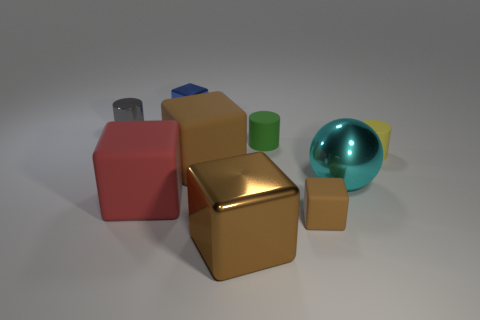Does the metallic sphere have the same size as the metallic object in front of the large metal sphere?
Provide a succinct answer. Yes. Are there an equal number of large brown metal cubes that are left of the gray metal cylinder and small yellow cylinders that are to the right of the small green matte cylinder?
Keep it short and to the point. No. What is the shape of the matte thing that is the same color as the tiny rubber block?
Offer a very short reply. Cube. There is a cylinder on the left side of the blue metallic thing; what is its material?
Your answer should be compact. Metal. Do the green rubber cylinder and the brown shiny object have the same size?
Keep it short and to the point. No. Are there more matte cylinders that are on the left side of the big brown metallic block than large red cylinders?
Keep it short and to the point. No. What size is the green cylinder that is the same material as the red block?
Give a very brief answer. Small. There is a small yellow rubber cylinder; are there any red matte blocks behind it?
Give a very brief answer. No. Do the blue thing and the big brown metal thing have the same shape?
Make the answer very short. Yes. There is a brown matte object that is left of the metal cube in front of the small cube behind the tiny matte cube; how big is it?
Make the answer very short. Large. 